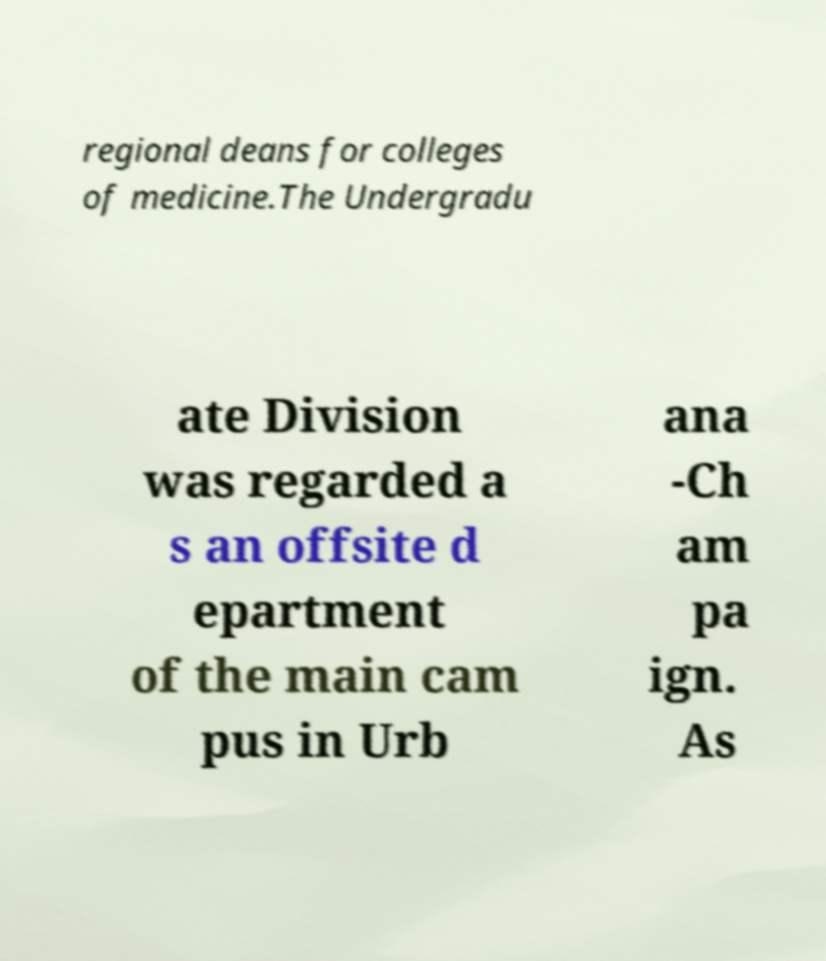Please identify and transcribe the text found in this image. regional deans for colleges of medicine.The Undergradu ate Division was regarded a s an offsite d epartment of the main cam pus in Urb ana -Ch am pa ign. As 